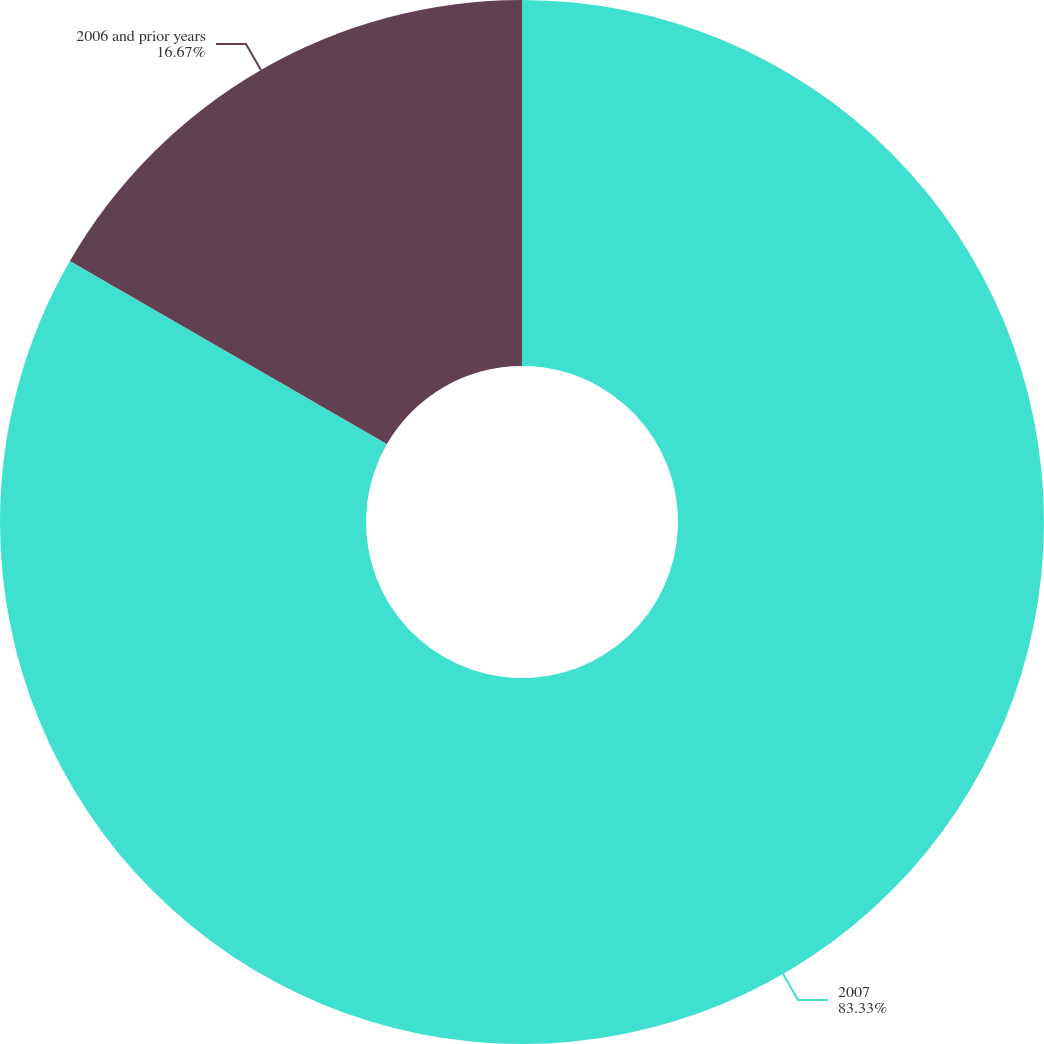Convert chart. <chart><loc_0><loc_0><loc_500><loc_500><pie_chart><fcel>2007<fcel>2006 and prior years<nl><fcel>83.33%<fcel>16.67%<nl></chart> 